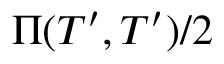Convert formula to latex. <formula><loc_0><loc_0><loc_500><loc_500>\Pi ( T ^ { \prime } , T ^ { \prime } ) / 2</formula> 